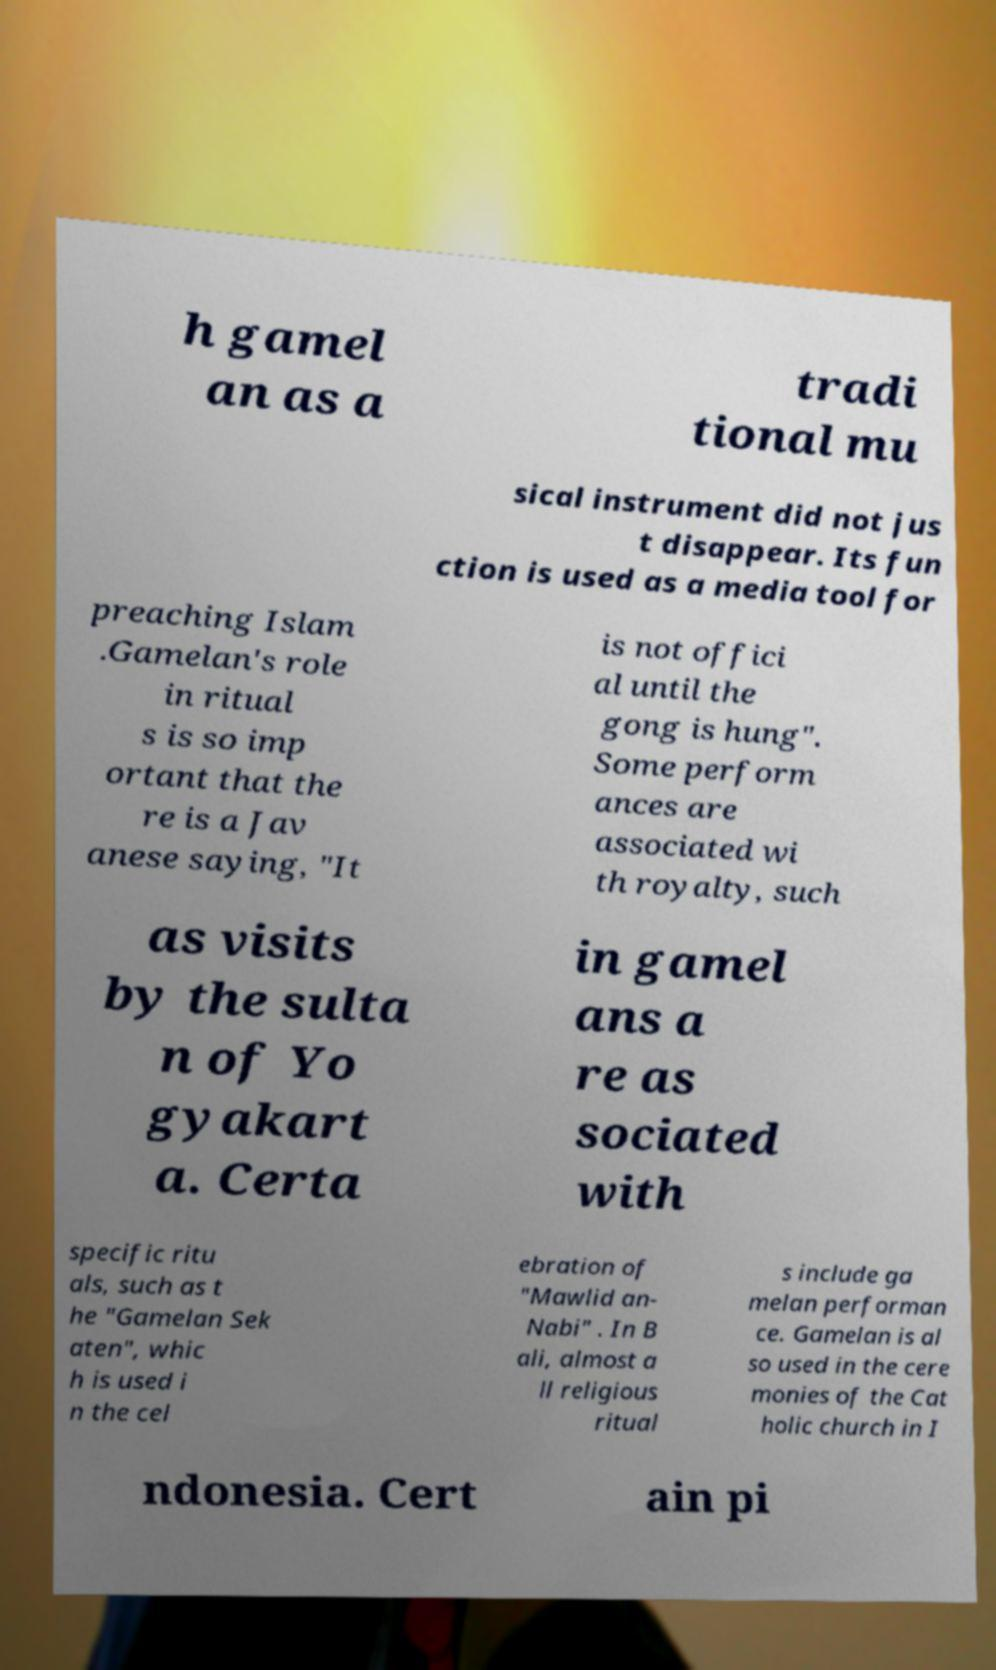What messages or text are displayed in this image? I need them in a readable, typed format. h gamel an as a tradi tional mu sical instrument did not jus t disappear. Its fun ction is used as a media tool for preaching Islam .Gamelan's role in ritual s is so imp ortant that the re is a Jav anese saying, "It is not offici al until the gong is hung". Some perform ances are associated wi th royalty, such as visits by the sulta n of Yo gyakart a. Certa in gamel ans a re as sociated with specific ritu als, such as t he "Gamelan Sek aten", whic h is used i n the cel ebration of "Mawlid an- Nabi" . In B ali, almost a ll religious ritual s include ga melan performan ce. Gamelan is al so used in the cere monies of the Cat holic church in I ndonesia. Cert ain pi 